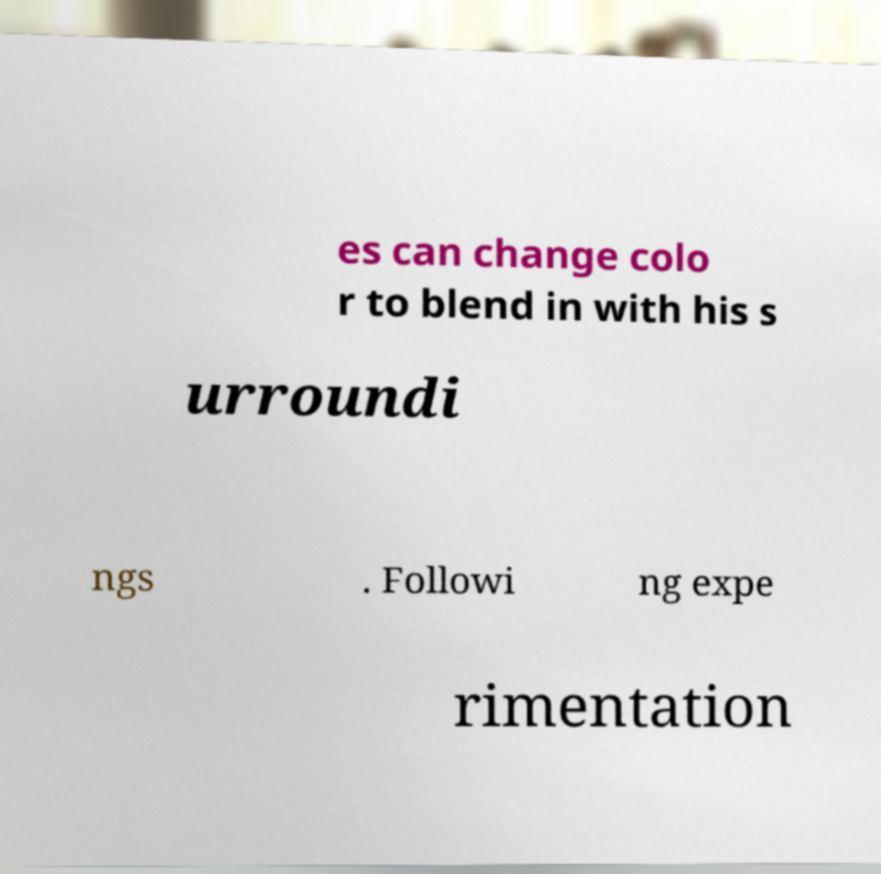What messages or text are displayed in this image? I need them in a readable, typed format. es can change colo r to blend in with his s urroundi ngs . Followi ng expe rimentation 